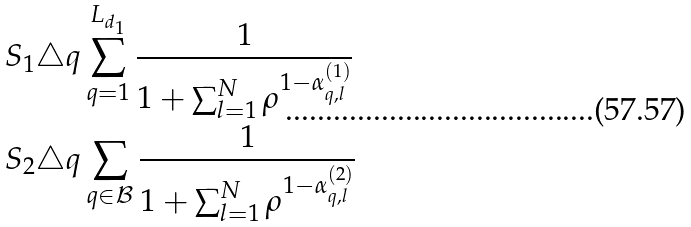<formula> <loc_0><loc_0><loc_500><loc_500>S _ { 1 } & \triangle q \sum _ { q = 1 } ^ { L _ { d _ { 1 } } } \frac { 1 } { 1 + \sum _ { l = 1 } ^ { N } \rho ^ { 1 - \alpha ^ { ( 1 ) } _ { q , l } } } \\ S _ { 2 } & \triangle q \sum _ { q \in \mathcal { B } } \frac { 1 } { 1 + \sum _ { l = 1 } ^ { N } \rho ^ { 1 - \alpha ^ { ( 2 ) } _ { q , l } } }</formula> 